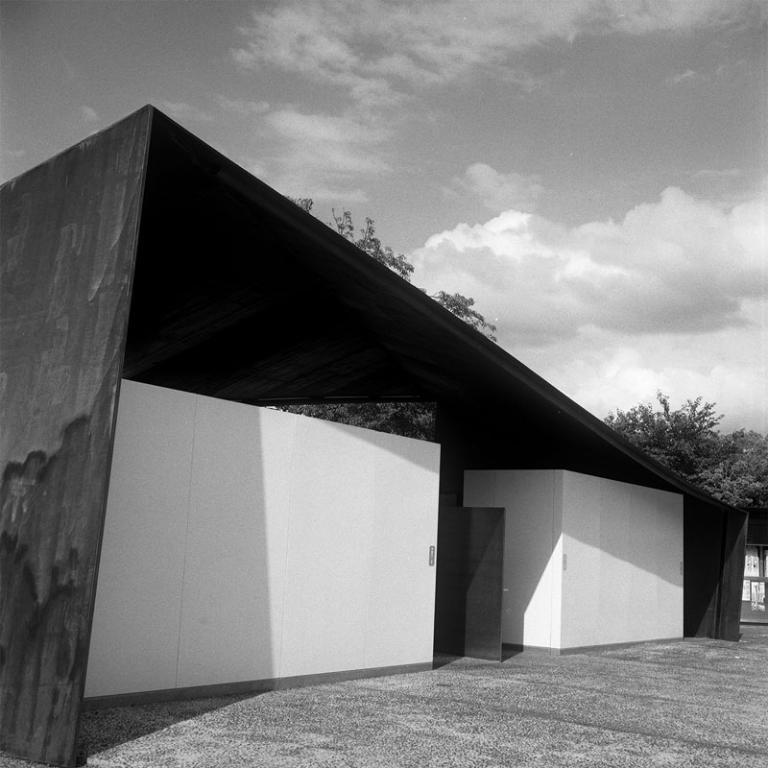Please provide a concise description of this image. This is a black and white image. In the foreground we can see the ground and white color objects under the shade. In the background there is a sky which is full of clouds and we can see the trees. 